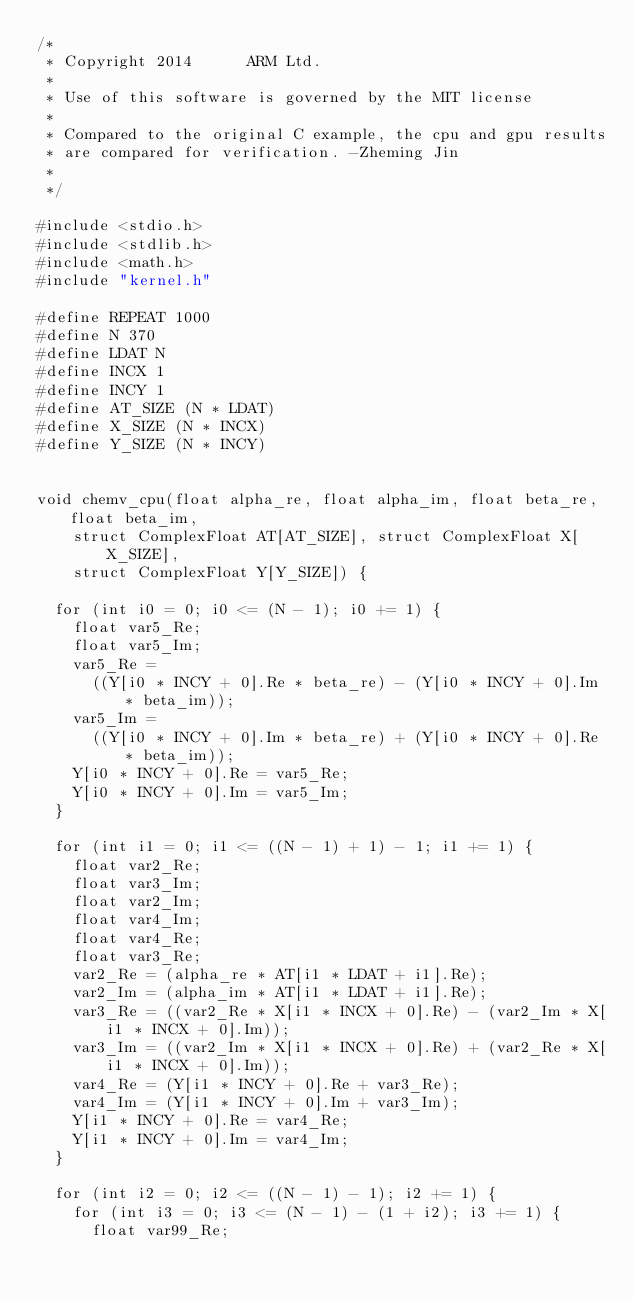Convert code to text. <code><loc_0><loc_0><loc_500><loc_500><_Cuda_>/*
 * Copyright 2014      ARM Ltd.
 *
 * Use of this software is governed by the MIT license
 *
 * Compared to the original C example, the cpu and gpu results 
 * are compared for verification. -Zheming Jin
 *   
 */

#include <stdio.h>
#include <stdlib.h>
#include <math.h>
#include "kernel.h"

#define REPEAT 1000
#define N 370
#define LDAT N
#define INCX 1
#define INCY 1
#define AT_SIZE (N * LDAT)
#define X_SIZE (N * INCX)
#define Y_SIZE (N * INCY)


void chemv_cpu(float alpha_re, float alpha_im, float beta_re, float beta_im,
    struct ComplexFloat AT[AT_SIZE], struct ComplexFloat X[X_SIZE],
    struct ComplexFloat Y[Y_SIZE]) {

  for (int i0 = 0; i0 <= (N - 1); i0 += 1) {
    float var5_Re;
    float var5_Im;
    var5_Re =
      ((Y[i0 * INCY + 0].Re * beta_re) - (Y[i0 * INCY + 0].Im * beta_im));
    var5_Im =
      ((Y[i0 * INCY + 0].Im * beta_re) + (Y[i0 * INCY + 0].Re * beta_im));
    Y[i0 * INCY + 0].Re = var5_Re;
    Y[i0 * INCY + 0].Im = var5_Im;
  }

  for (int i1 = 0; i1 <= ((N - 1) + 1) - 1; i1 += 1) {
    float var2_Re;
    float var3_Im;
    float var2_Im;
    float var4_Im;
    float var4_Re;
    float var3_Re;
    var2_Re = (alpha_re * AT[i1 * LDAT + i1].Re);
    var2_Im = (alpha_im * AT[i1 * LDAT + i1].Re);
    var3_Re = ((var2_Re * X[i1 * INCX + 0].Re) - (var2_Im * X[i1 * INCX + 0].Im));
    var3_Im = ((var2_Im * X[i1 * INCX + 0].Re) + (var2_Re * X[i1 * INCX + 0].Im));
    var4_Re = (Y[i1 * INCY + 0].Re + var3_Re);
    var4_Im = (Y[i1 * INCY + 0].Im + var3_Im);
    Y[i1 * INCY + 0].Re = var4_Re;
    Y[i1 * INCY + 0].Im = var4_Im;
  }

  for (int i2 = 0; i2 <= ((N - 1) - 1); i2 += 1) {
    for (int i3 = 0; i3 <= (N - 1) - (1 + i2); i3 += 1) {
      float var99_Re;</code> 